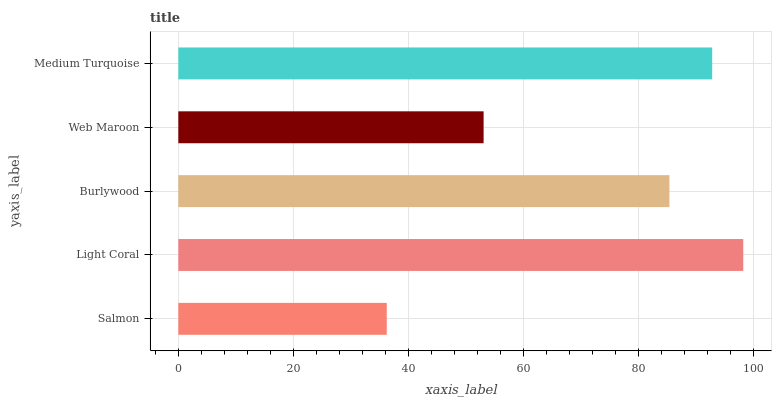Is Salmon the minimum?
Answer yes or no. Yes. Is Light Coral the maximum?
Answer yes or no. Yes. Is Burlywood the minimum?
Answer yes or no. No. Is Burlywood the maximum?
Answer yes or no. No. Is Light Coral greater than Burlywood?
Answer yes or no. Yes. Is Burlywood less than Light Coral?
Answer yes or no. Yes. Is Burlywood greater than Light Coral?
Answer yes or no. No. Is Light Coral less than Burlywood?
Answer yes or no. No. Is Burlywood the high median?
Answer yes or no. Yes. Is Burlywood the low median?
Answer yes or no. Yes. Is Medium Turquoise the high median?
Answer yes or no. No. Is Salmon the low median?
Answer yes or no. No. 